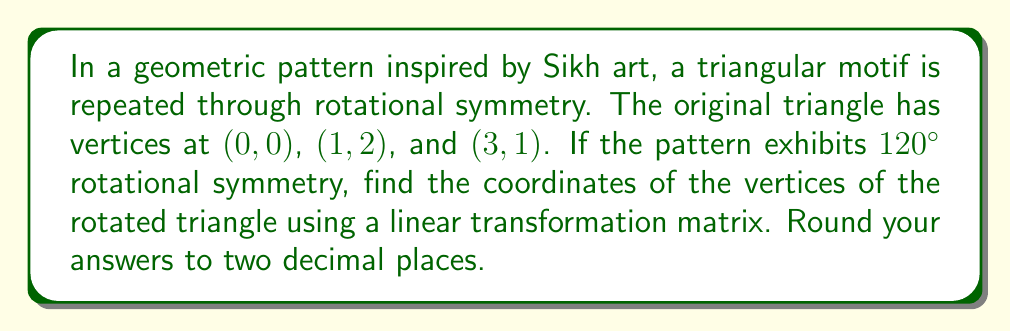Can you answer this question? Let's approach this step-by-step:

1) First, we need to recall the rotation matrix for a counterclockwise rotation by θ degrees:

   $$R = \begin{bmatrix} \cos θ & -\sin θ \\ \sin θ & \cos θ \end{bmatrix}$$

2) In this case, θ = 120°. Let's calculate the values:

   $$\cos 120° = -\frac{1}{2}$$
   $$\sin 120° = \frac{\sqrt{3}}{2}$$

3) Substituting these values into our rotation matrix:

   $$R = \begin{bmatrix} -\frac{1}{2} & -\frac{\sqrt{3}}{2} \\ \frac{\sqrt{3}}{2} & -\frac{1}{2} \end{bmatrix}$$

4) Now, we need to apply this transformation to each vertex. Let's start with (0,0):

   $$\begin{bmatrix} -\frac{1}{2} & -\frac{\sqrt{3}}{2} \\ \frac{\sqrt{3}}{2} & -\frac{1}{2} \end{bmatrix} \begin{bmatrix} 0 \\ 0 \end{bmatrix} = \begin{bmatrix} 0 \\ 0 \end{bmatrix}$$

5) For (1,2):

   $$\begin{bmatrix} -\frac{1}{2} & -\frac{\sqrt{3}}{2} \\ \frac{\sqrt{3}}{2} & -\frac{1}{2} \end{bmatrix} \begin{bmatrix} 1 \\ 2 \end{bmatrix} = \begin{bmatrix} -\frac{1}{2} - \sqrt{3} \\ \frac{\sqrt{3}}{2} - 1 \end{bmatrix} \approx \begin{bmatrix} -2.23 \\ -0.13 \end{bmatrix}$$

6) For (3,1):

   $$\begin{bmatrix} -\frac{1}{2} & -\frac{\sqrt{3}}{2} \\ \frac{\sqrt{3}}{2} & -\frac{1}{2} \end{bmatrix} \begin{bmatrix} 3 \\ 1 \end{bmatrix} = \begin{bmatrix} -\frac{3}{2} - \frac{\sqrt{3}}{2} \\ \frac{3\sqrt{3}}{2} - \frac{1}{2} \end{bmatrix} \approx \begin{bmatrix} -2.37 \\ 2.10 \end{bmatrix}$$

Therefore, the vertices of the rotated triangle are approximately (0,0), (-2.23, -0.13), and (-2.37, 2.10).
Answer: (0,0), (-2.23, -0.13), (-2.37, 2.10) 